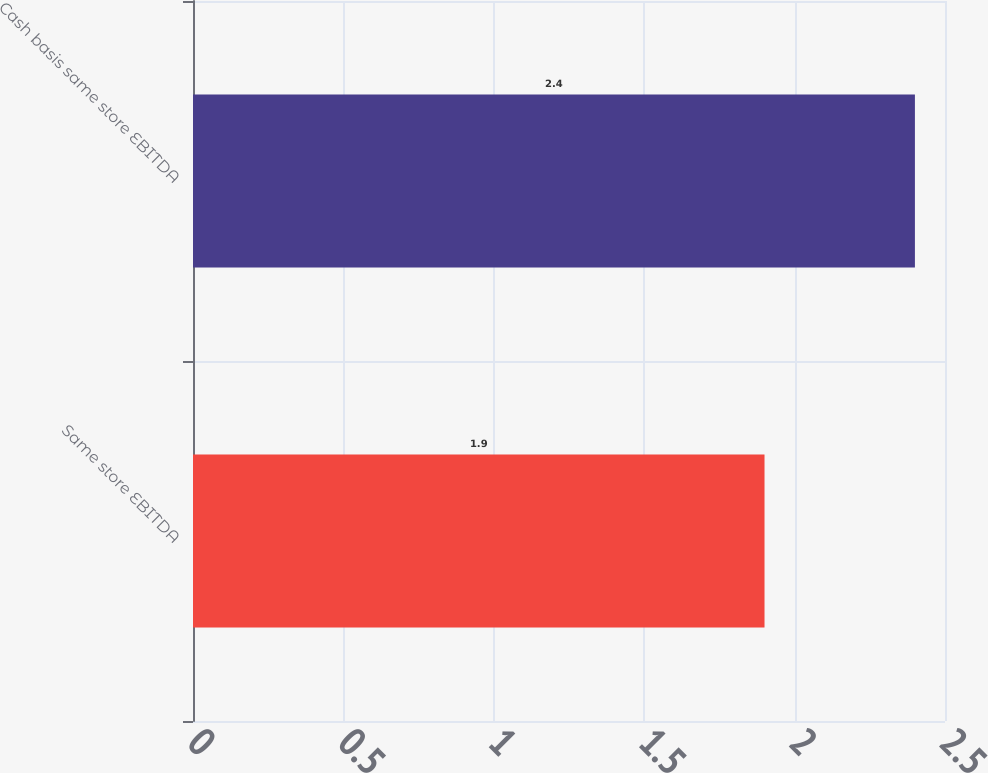Convert chart to OTSL. <chart><loc_0><loc_0><loc_500><loc_500><bar_chart><fcel>Same store EBITDA<fcel>Cash basis same store EBITDA<nl><fcel>1.9<fcel>2.4<nl></chart> 